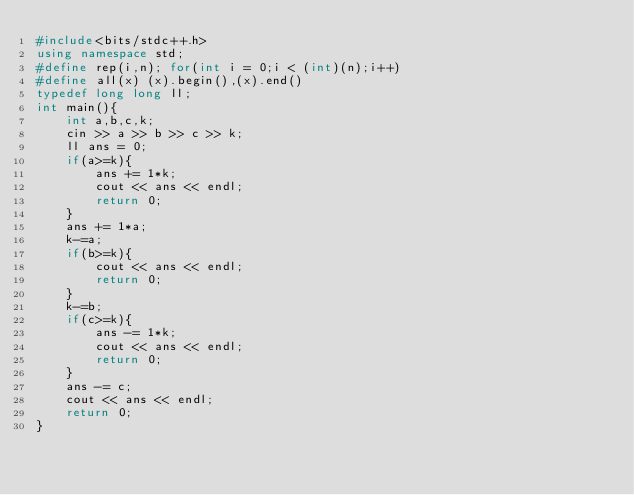<code> <loc_0><loc_0><loc_500><loc_500><_C++_>#include<bits/stdc++.h>
using namespace std;
#define rep(i,n); for(int i = 0;i < (int)(n);i++)
#define all(x) (x).begin(),(x).end()
typedef long long ll;
int main(){
    int a,b,c,k;
    cin >> a >> b >> c >> k;
    ll ans = 0;
    if(a>=k){
        ans += 1*k;
        cout << ans << endl;
        return 0;
    }
    ans += 1*a;
    k-=a;
    if(b>=k){
        cout << ans << endl;
        return 0;
    }
    k-=b;
    if(c>=k){
        ans -= 1*k;
        cout << ans << endl;
        return 0;
    }
    ans -= c;
    cout << ans << endl;
    return 0;
}</code> 